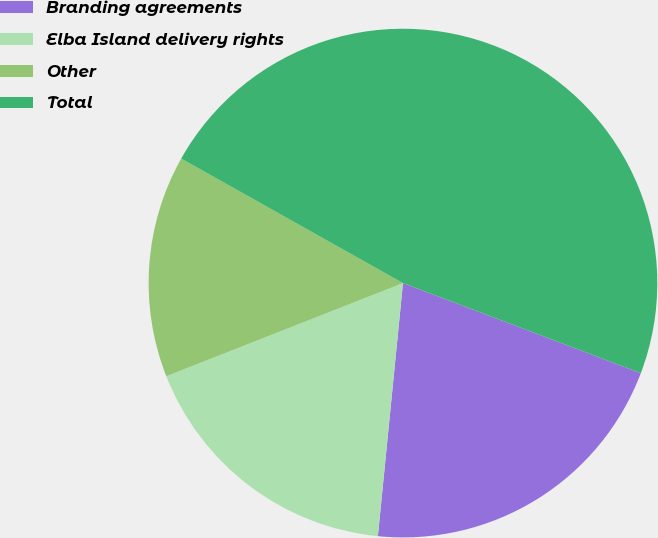<chart> <loc_0><loc_0><loc_500><loc_500><pie_chart><fcel>Branding agreements<fcel>Elba Island delivery rights<fcel>Other<fcel>Total<nl><fcel>20.81%<fcel>17.46%<fcel>14.11%<fcel>47.62%<nl></chart> 